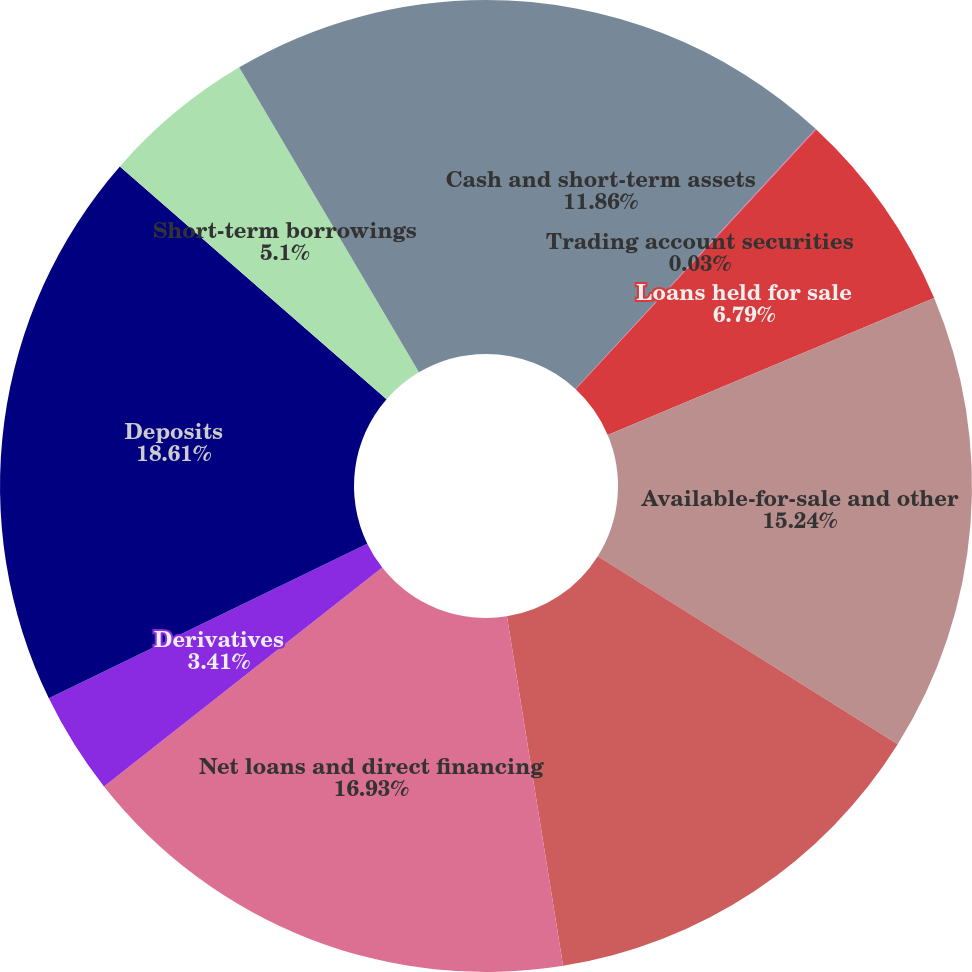Convert chart to OTSL. <chart><loc_0><loc_0><loc_500><loc_500><pie_chart><fcel>Cash and short-term assets<fcel>Trading account securities<fcel>Loans held for sale<fcel>Available-for-sale and other<fcel>Held-to-maturity securities<fcel>Net loans and direct financing<fcel>Derivatives<fcel>Deposits<fcel>Short-term borrowings<fcel>Federal Home Loan Bank<nl><fcel>11.86%<fcel>0.03%<fcel>6.79%<fcel>15.24%<fcel>13.55%<fcel>16.93%<fcel>3.41%<fcel>18.62%<fcel>5.1%<fcel>8.48%<nl></chart> 